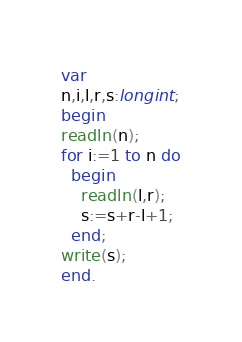Convert code to text. <code><loc_0><loc_0><loc_500><loc_500><_Pascal_>var
n,i,l,r,s:longint;
begin
readln(n);
for i:=1 to n do
  begin
    readln(l,r);
    s:=s+r-l+1;
  end;
write(s);
end.</code> 